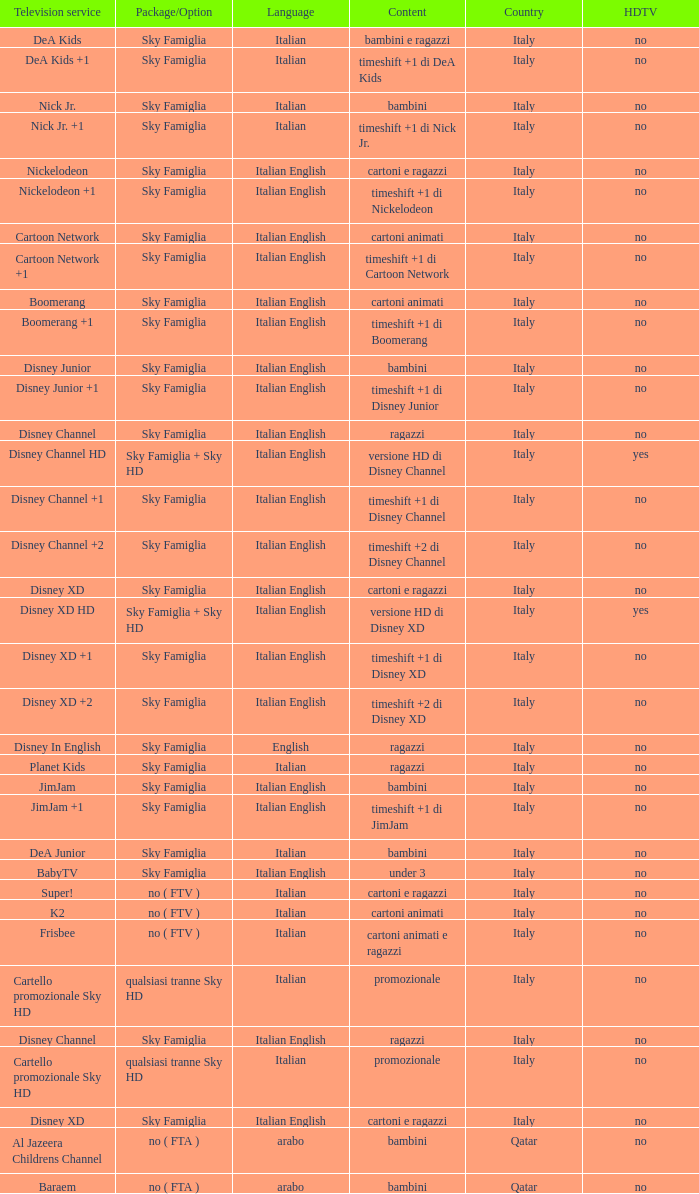What is the HDTV when the content shows a timeshift +1 di disney junior? No. 